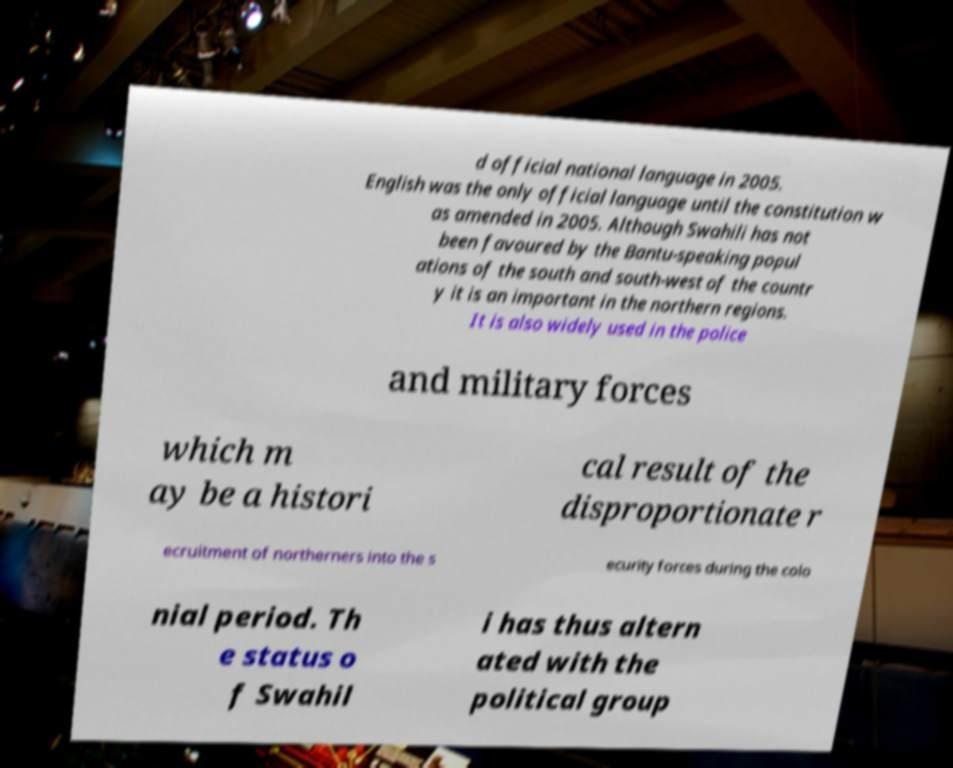What messages or text are displayed in this image? I need them in a readable, typed format. d official national language in 2005. English was the only official language until the constitution w as amended in 2005. Although Swahili has not been favoured by the Bantu-speaking popul ations of the south and south-west of the countr y it is an important in the northern regions. It is also widely used in the police and military forces which m ay be a histori cal result of the disproportionate r ecruitment of northerners into the s ecurity forces during the colo nial period. Th e status o f Swahil i has thus altern ated with the political group 